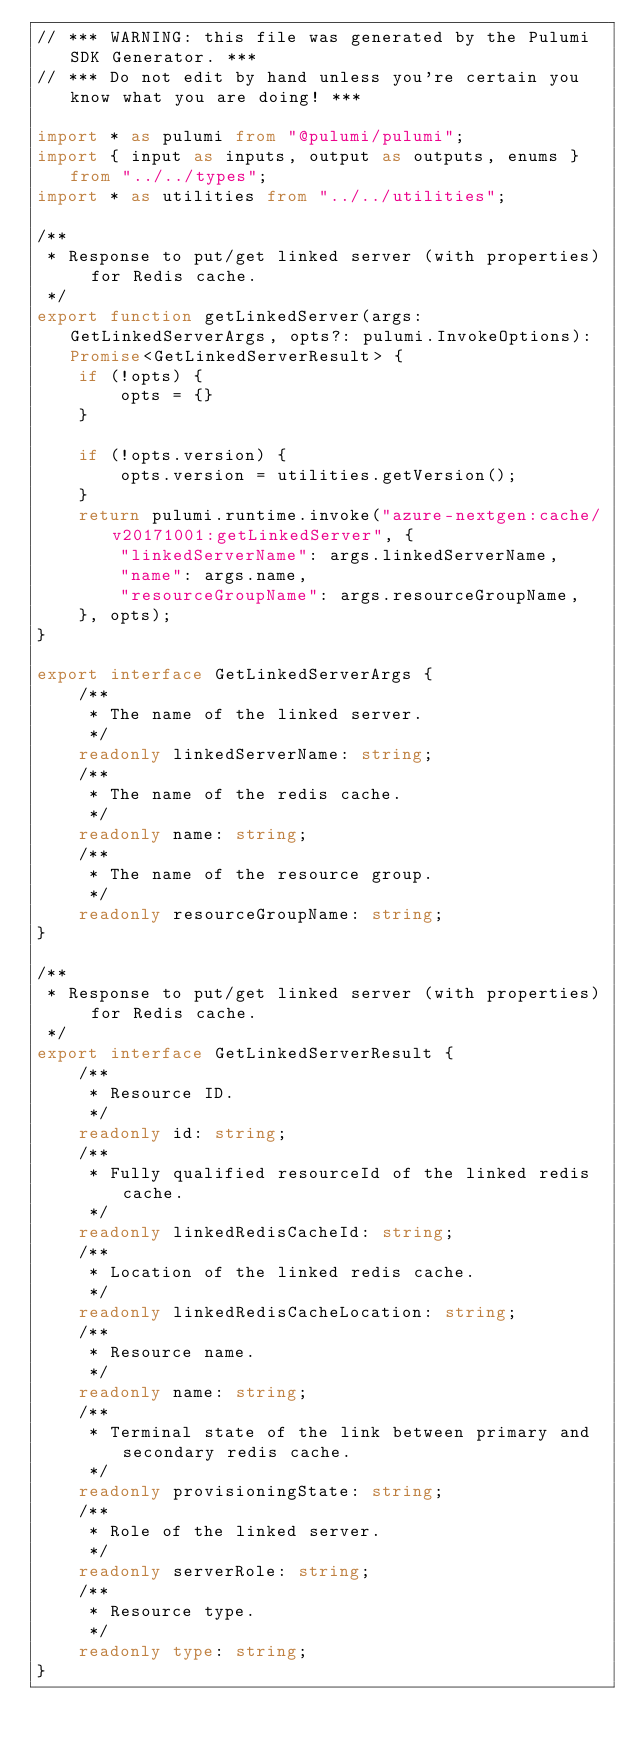<code> <loc_0><loc_0><loc_500><loc_500><_TypeScript_>// *** WARNING: this file was generated by the Pulumi SDK Generator. ***
// *** Do not edit by hand unless you're certain you know what you are doing! ***

import * as pulumi from "@pulumi/pulumi";
import { input as inputs, output as outputs, enums } from "../../types";
import * as utilities from "../../utilities";

/**
 * Response to put/get linked server (with properties) for Redis cache.
 */
export function getLinkedServer(args: GetLinkedServerArgs, opts?: pulumi.InvokeOptions): Promise<GetLinkedServerResult> {
    if (!opts) {
        opts = {}
    }

    if (!opts.version) {
        opts.version = utilities.getVersion();
    }
    return pulumi.runtime.invoke("azure-nextgen:cache/v20171001:getLinkedServer", {
        "linkedServerName": args.linkedServerName,
        "name": args.name,
        "resourceGroupName": args.resourceGroupName,
    }, opts);
}

export interface GetLinkedServerArgs {
    /**
     * The name of the linked server.
     */
    readonly linkedServerName: string;
    /**
     * The name of the redis cache.
     */
    readonly name: string;
    /**
     * The name of the resource group.
     */
    readonly resourceGroupName: string;
}

/**
 * Response to put/get linked server (with properties) for Redis cache.
 */
export interface GetLinkedServerResult {
    /**
     * Resource ID.
     */
    readonly id: string;
    /**
     * Fully qualified resourceId of the linked redis cache.
     */
    readonly linkedRedisCacheId: string;
    /**
     * Location of the linked redis cache.
     */
    readonly linkedRedisCacheLocation: string;
    /**
     * Resource name.
     */
    readonly name: string;
    /**
     * Terminal state of the link between primary and secondary redis cache.
     */
    readonly provisioningState: string;
    /**
     * Role of the linked server.
     */
    readonly serverRole: string;
    /**
     * Resource type.
     */
    readonly type: string;
}
</code> 